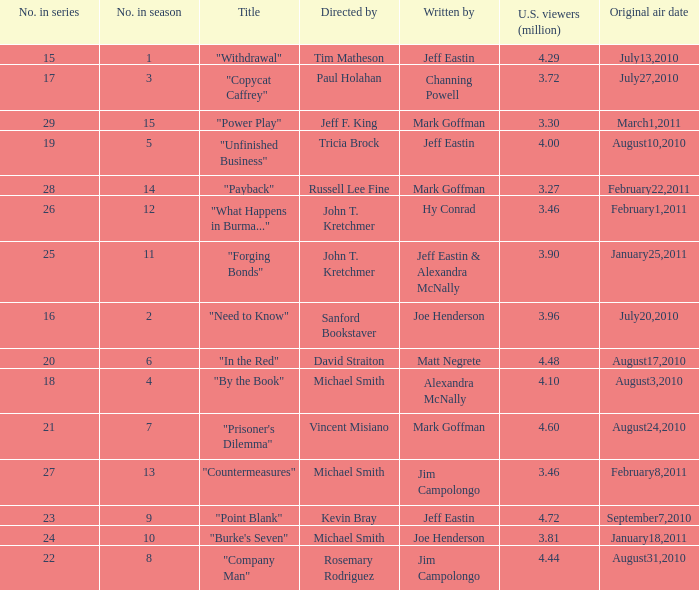How many millions of people in the US watched the "Company Man" episode? 4.44. 